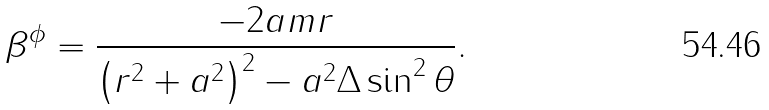<formula> <loc_0><loc_0><loc_500><loc_500>\beta ^ { \phi } = \frac { - 2 a m r } { \left ( r ^ { 2 } + a ^ { 2 } \right ) ^ { 2 } - a ^ { 2 } \Delta \sin ^ { 2 } \theta } .</formula> 